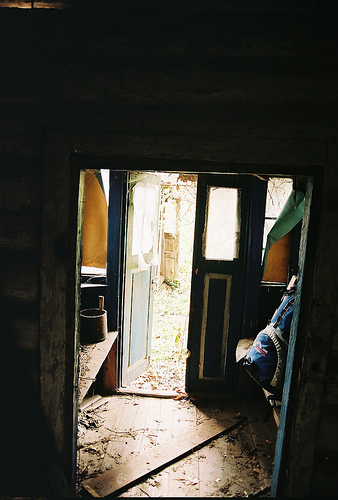<image>
Is there a yard in front of the door? Yes. The yard is positioned in front of the door, appearing closer to the camera viewpoint. 